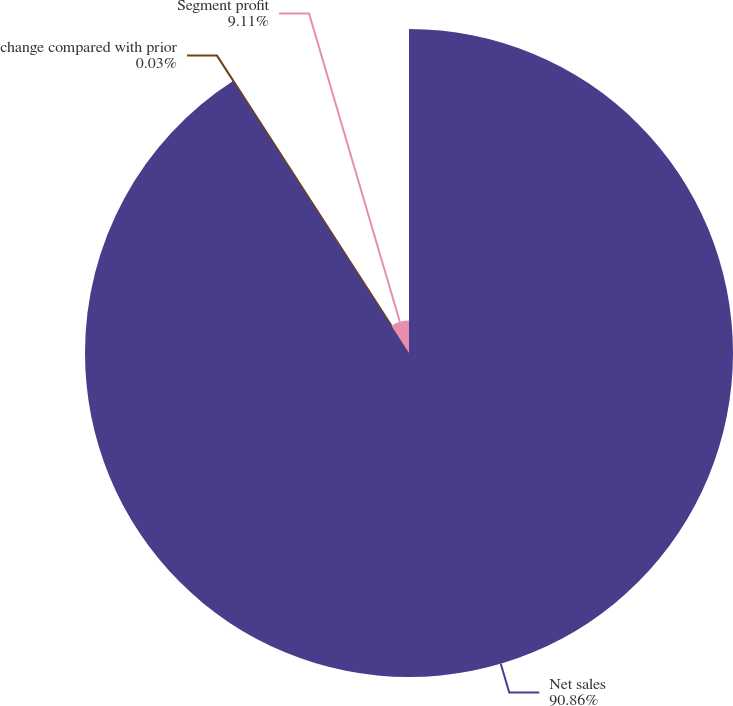Convert chart. <chart><loc_0><loc_0><loc_500><loc_500><pie_chart><fcel>Net sales<fcel>change compared with prior<fcel>Segment profit<nl><fcel>90.86%<fcel>0.03%<fcel>9.11%<nl></chart> 